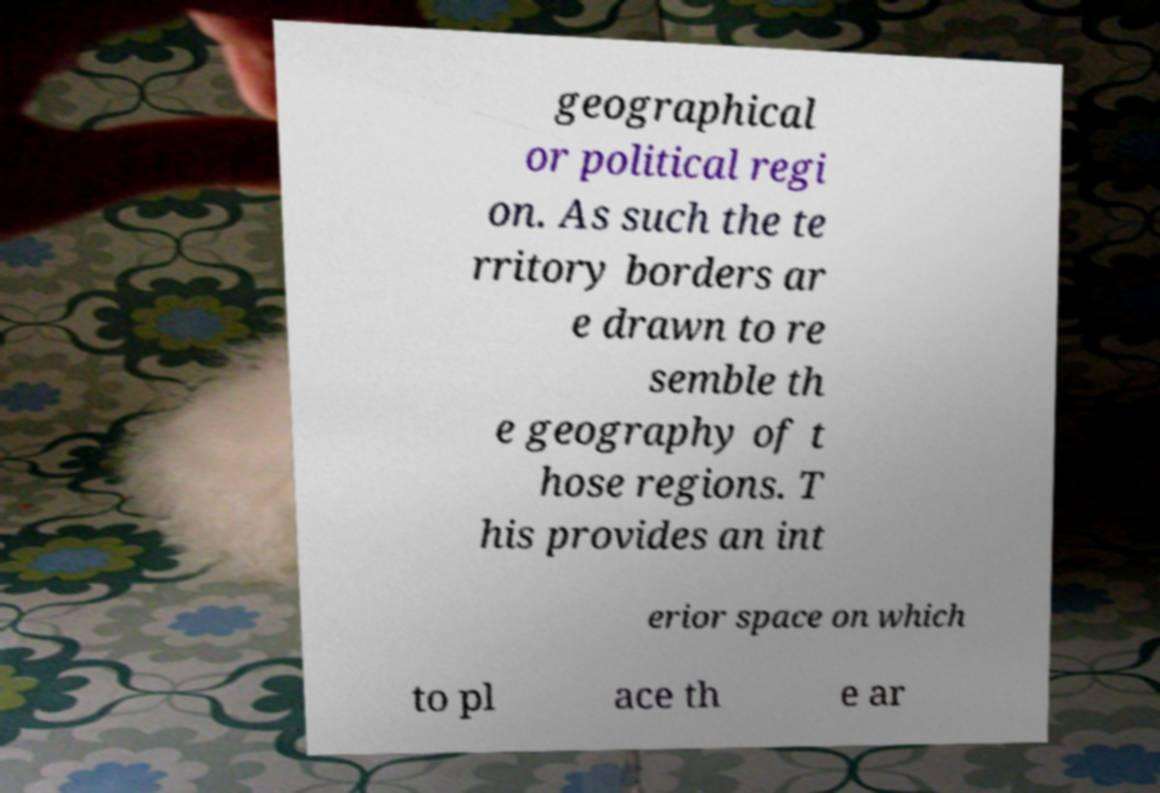I need the written content from this picture converted into text. Can you do that? geographical or political regi on. As such the te rritory borders ar e drawn to re semble th e geography of t hose regions. T his provides an int erior space on which to pl ace th e ar 